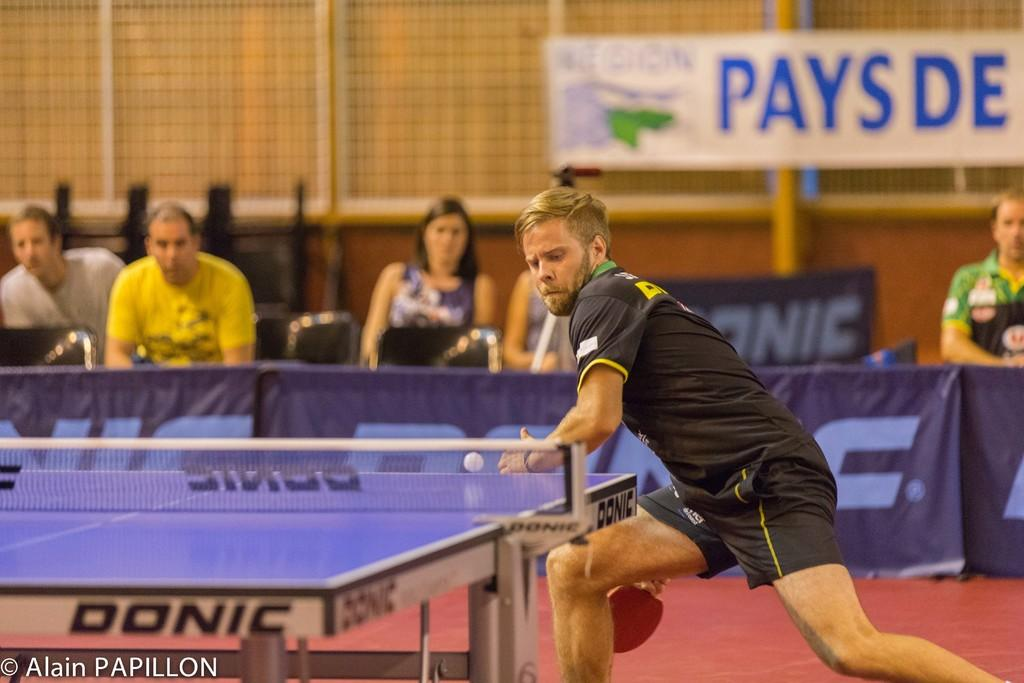What is the man in the image doing? The man is playing table tennis in the image. What action is the man attempting to perform? The man is trying to hit the ball. Can you describe the background of the image? There are persons sitting on chairs, a fence, a wall, and a banner in the background of the image. What type of brush is the man using to hit the ball in the image? There is no brush present in the image; the man is using a table tennis paddle to hit the ball. 